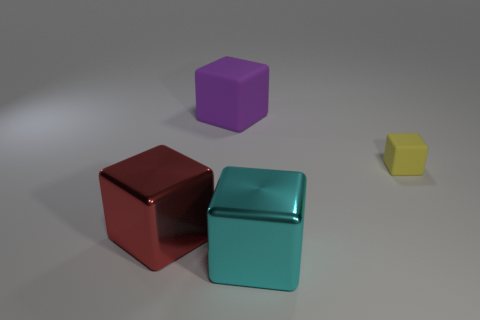Subtract all big cubes. How many cubes are left? 1 Add 3 shiny objects. How many objects exist? 7 Subtract 2 cubes. How many cubes are left? 2 Subtract all purple rubber things. Subtract all shiny things. How many objects are left? 1 Add 1 small rubber blocks. How many small rubber blocks are left? 2 Add 3 purple shiny balls. How many purple shiny balls exist? 3 Subtract all red blocks. How many blocks are left? 3 Subtract 0 blue cylinders. How many objects are left? 4 Subtract all cyan cubes. Subtract all yellow cylinders. How many cubes are left? 3 Subtract all purple cylinders. How many red cubes are left? 1 